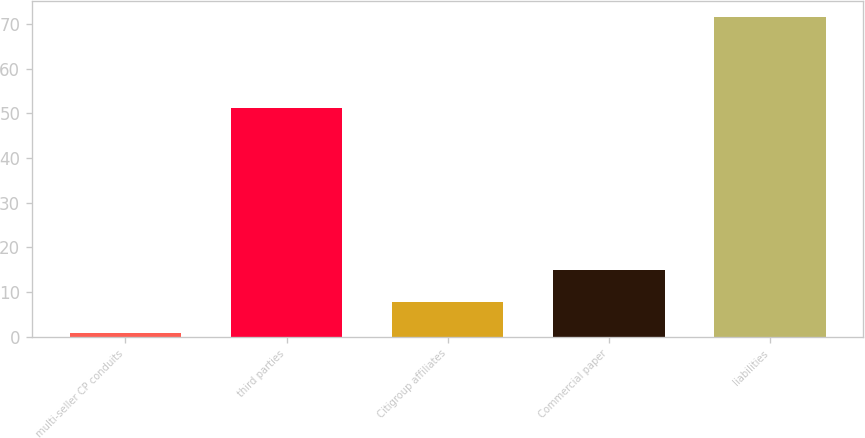Convert chart. <chart><loc_0><loc_0><loc_500><loc_500><bar_chart><fcel>multi-seller CP conduits<fcel>third parties<fcel>Citigroup affiliates<fcel>Commercial paper<fcel>liabilities<nl><fcel>0.8<fcel>51.2<fcel>7.87<fcel>14.94<fcel>71.5<nl></chart> 